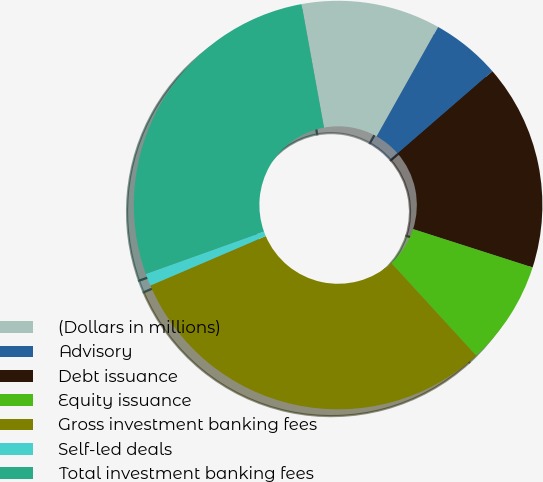<chart> <loc_0><loc_0><loc_500><loc_500><pie_chart><fcel>(Dollars in millions)<fcel>Advisory<fcel>Debt issuance<fcel>Equity issuance<fcel>Gross investment banking fees<fcel>Self-led deals<fcel>Total investment banking fees<nl><fcel>11.01%<fcel>5.49%<fcel>16.31%<fcel>8.25%<fcel>30.37%<fcel>0.97%<fcel>27.61%<nl></chart> 